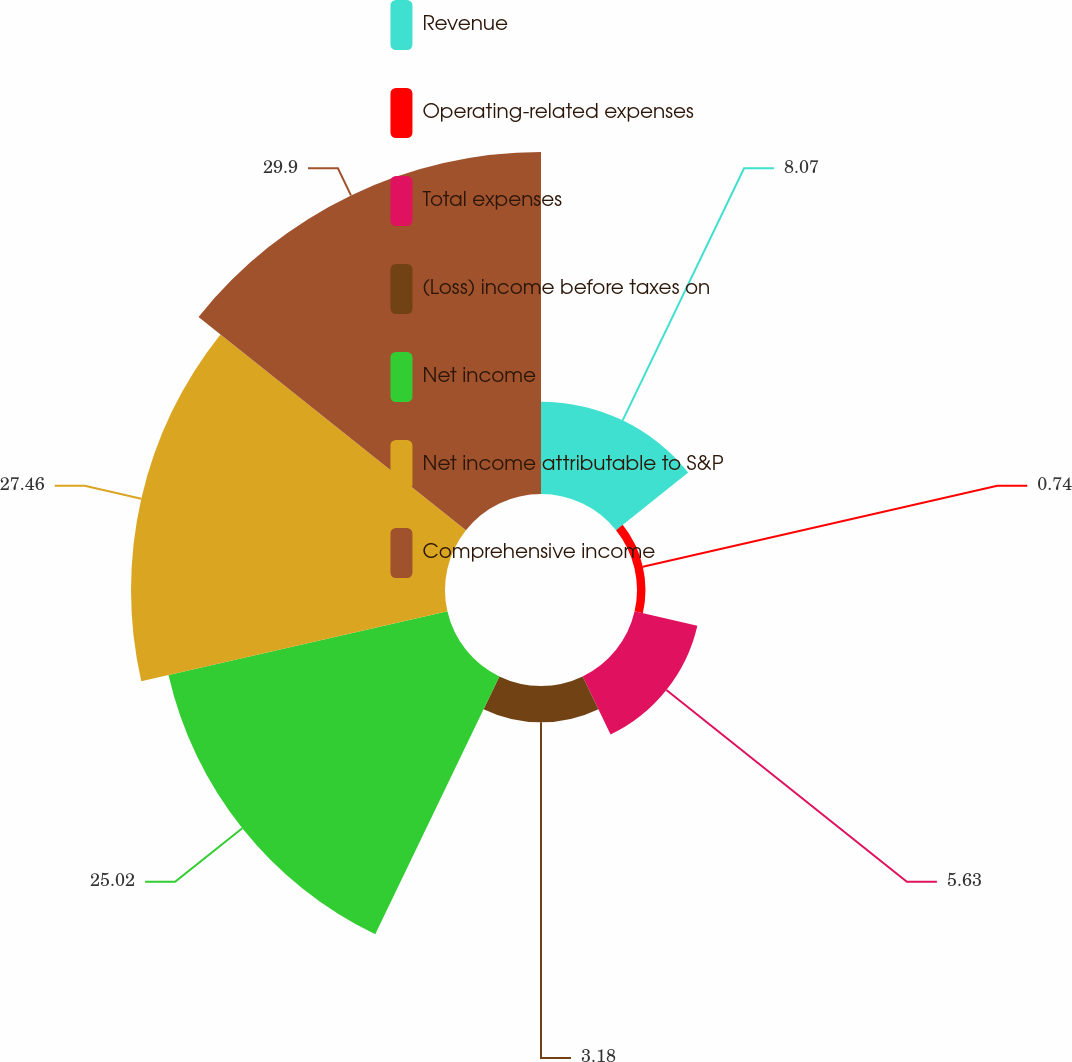Convert chart to OTSL. <chart><loc_0><loc_0><loc_500><loc_500><pie_chart><fcel>Revenue<fcel>Operating-related expenses<fcel>Total expenses<fcel>(Loss) income before taxes on<fcel>Net income<fcel>Net income attributable to S&P<fcel>Comprehensive income<nl><fcel>8.07%<fcel>0.74%<fcel>5.63%<fcel>3.18%<fcel>25.02%<fcel>27.46%<fcel>29.91%<nl></chart> 